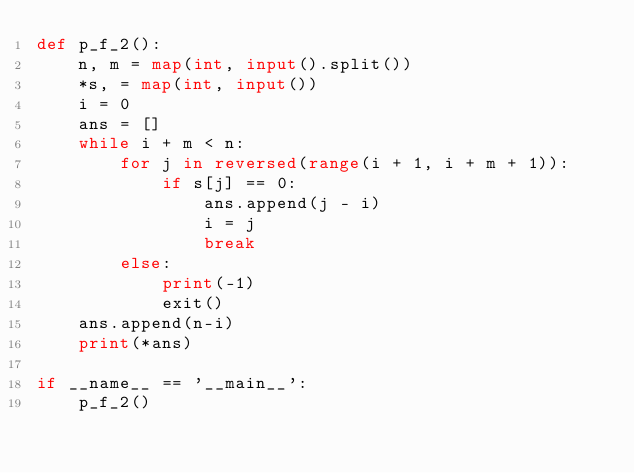Convert code to text. <code><loc_0><loc_0><loc_500><loc_500><_Python_>def p_f_2():
    n, m = map(int, input().split())
    *s, = map(int, input())
    i = 0
    ans = []
    while i + m < n:
        for j in reversed(range(i + 1, i + m + 1)):
            if s[j] == 0:
                ans.append(j - i)
                i = j
                break
        else:
            print(-1)
            exit()
    ans.append(n-i)
    print(*ans)

if __name__ == '__main__':
    p_f_2()
</code> 